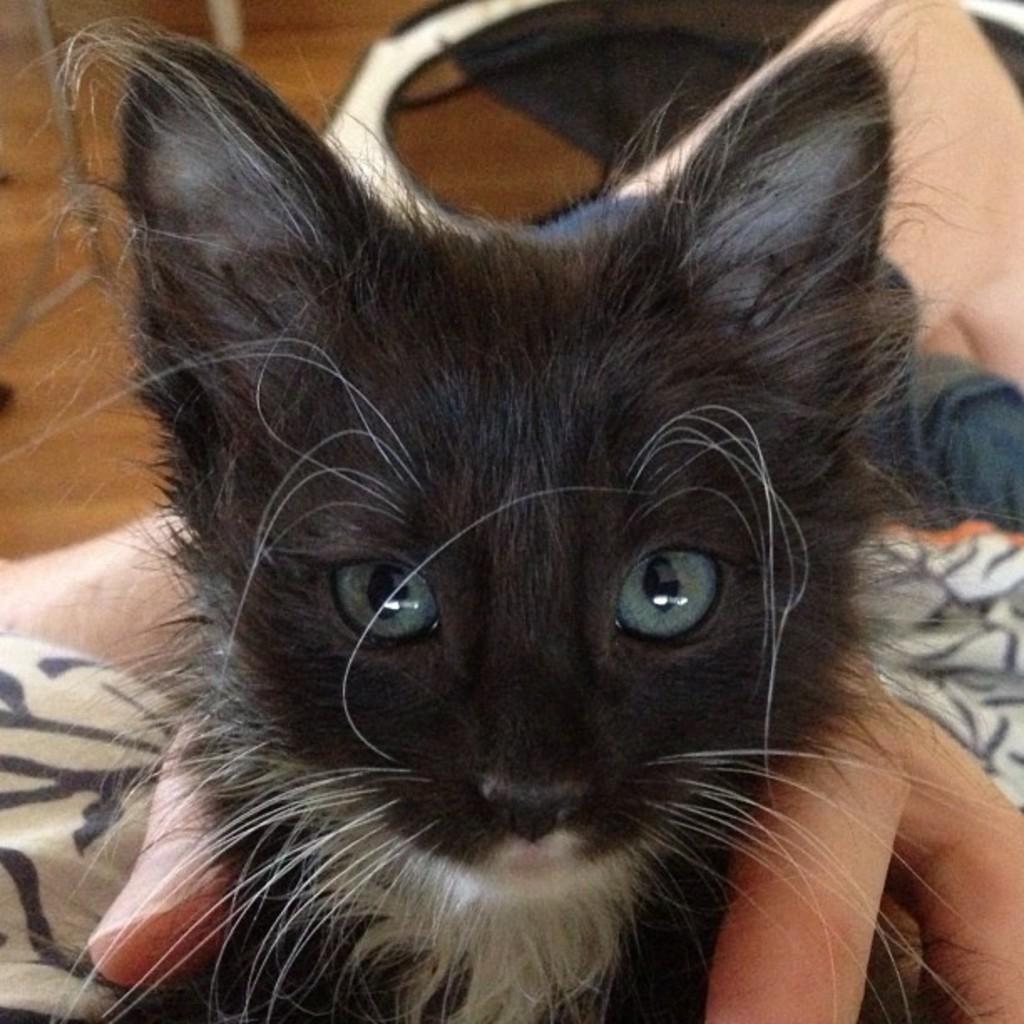Please provide a concise description of this image. In this image I can see a person holding a black color cat in the hand. The cat is looking at the picture. At the top of the image there are few objects on the floor. 